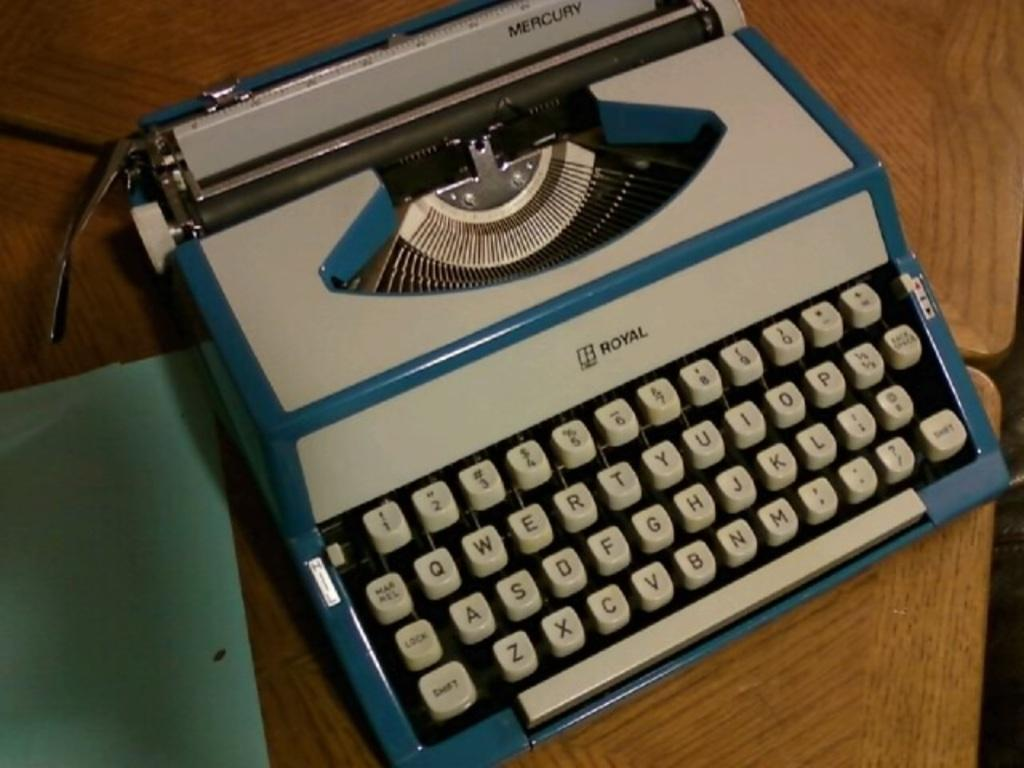<image>
Give a short and clear explanation of the subsequent image. An old white and blue typewriter from the manufacturer Royal. 